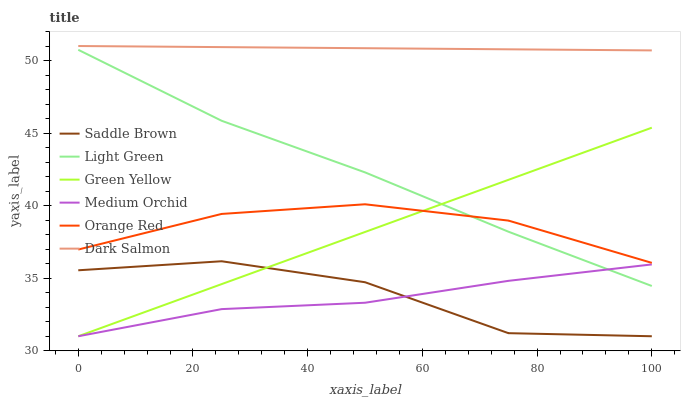Does Medium Orchid have the minimum area under the curve?
Answer yes or no. Yes. Does Dark Salmon have the maximum area under the curve?
Answer yes or no. Yes. Does Orange Red have the minimum area under the curve?
Answer yes or no. No. Does Orange Red have the maximum area under the curve?
Answer yes or no. No. Is Dark Salmon the smoothest?
Answer yes or no. Yes. Is Saddle Brown the roughest?
Answer yes or no. Yes. Is Orange Red the smoothest?
Answer yes or no. No. Is Orange Red the roughest?
Answer yes or no. No. Does Orange Red have the lowest value?
Answer yes or no. No. Does Dark Salmon have the highest value?
Answer yes or no. Yes. Does Orange Red have the highest value?
Answer yes or no. No. Is Green Yellow less than Dark Salmon?
Answer yes or no. Yes. Is Orange Red greater than Medium Orchid?
Answer yes or no. Yes. Does Light Green intersect Green Yellow?
Answer yes or no. Yes. Is Light Green less than Green Yellow?
Answer yes or no. No. Is Light Green greater than Green Yellow?
Answer yes or no. No. Does Green Yellow intersect Dark Salmon?
Answer yes or no. No. 